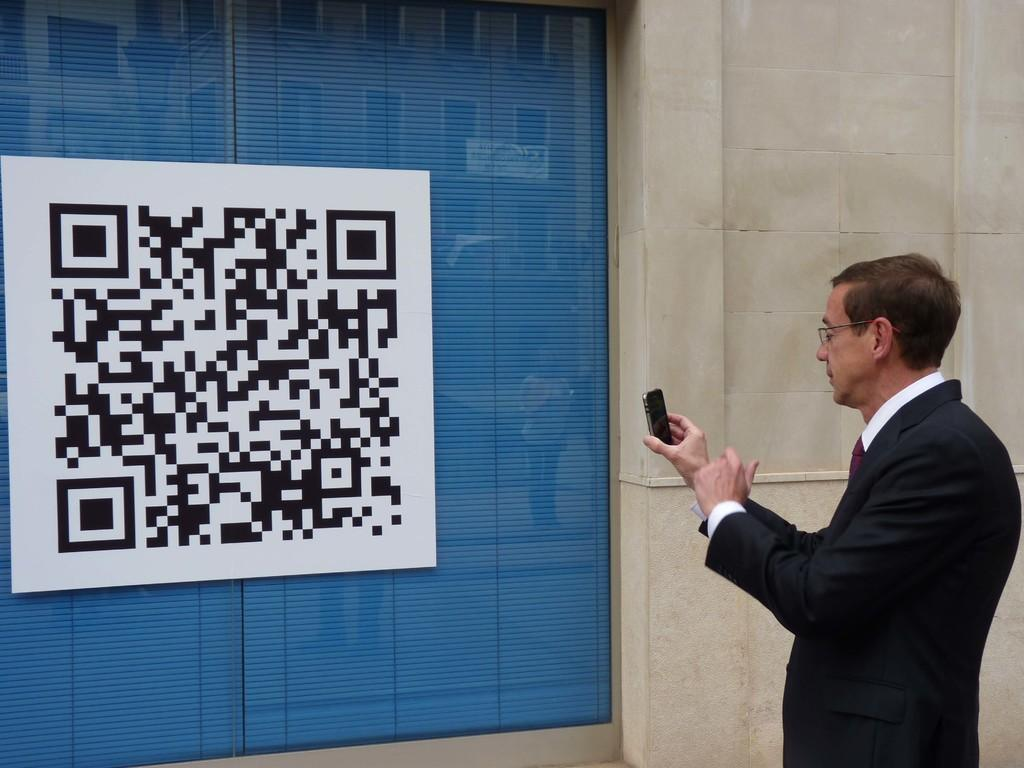What is the person in the image doing? The person is standing in the image. What object is the person holding? The person is holding a mobile phone. What can be seen on the wall in the image? There is a poster on the wall in the image. What type of structure is visible in the image? There is a wall in the image. What type of fireman is depicted in the image? There is no fireman present in the image. What kind of drug is being used by the person in the image? There is no indication of drug use in the image; the person is simply holding a mobile phone. 